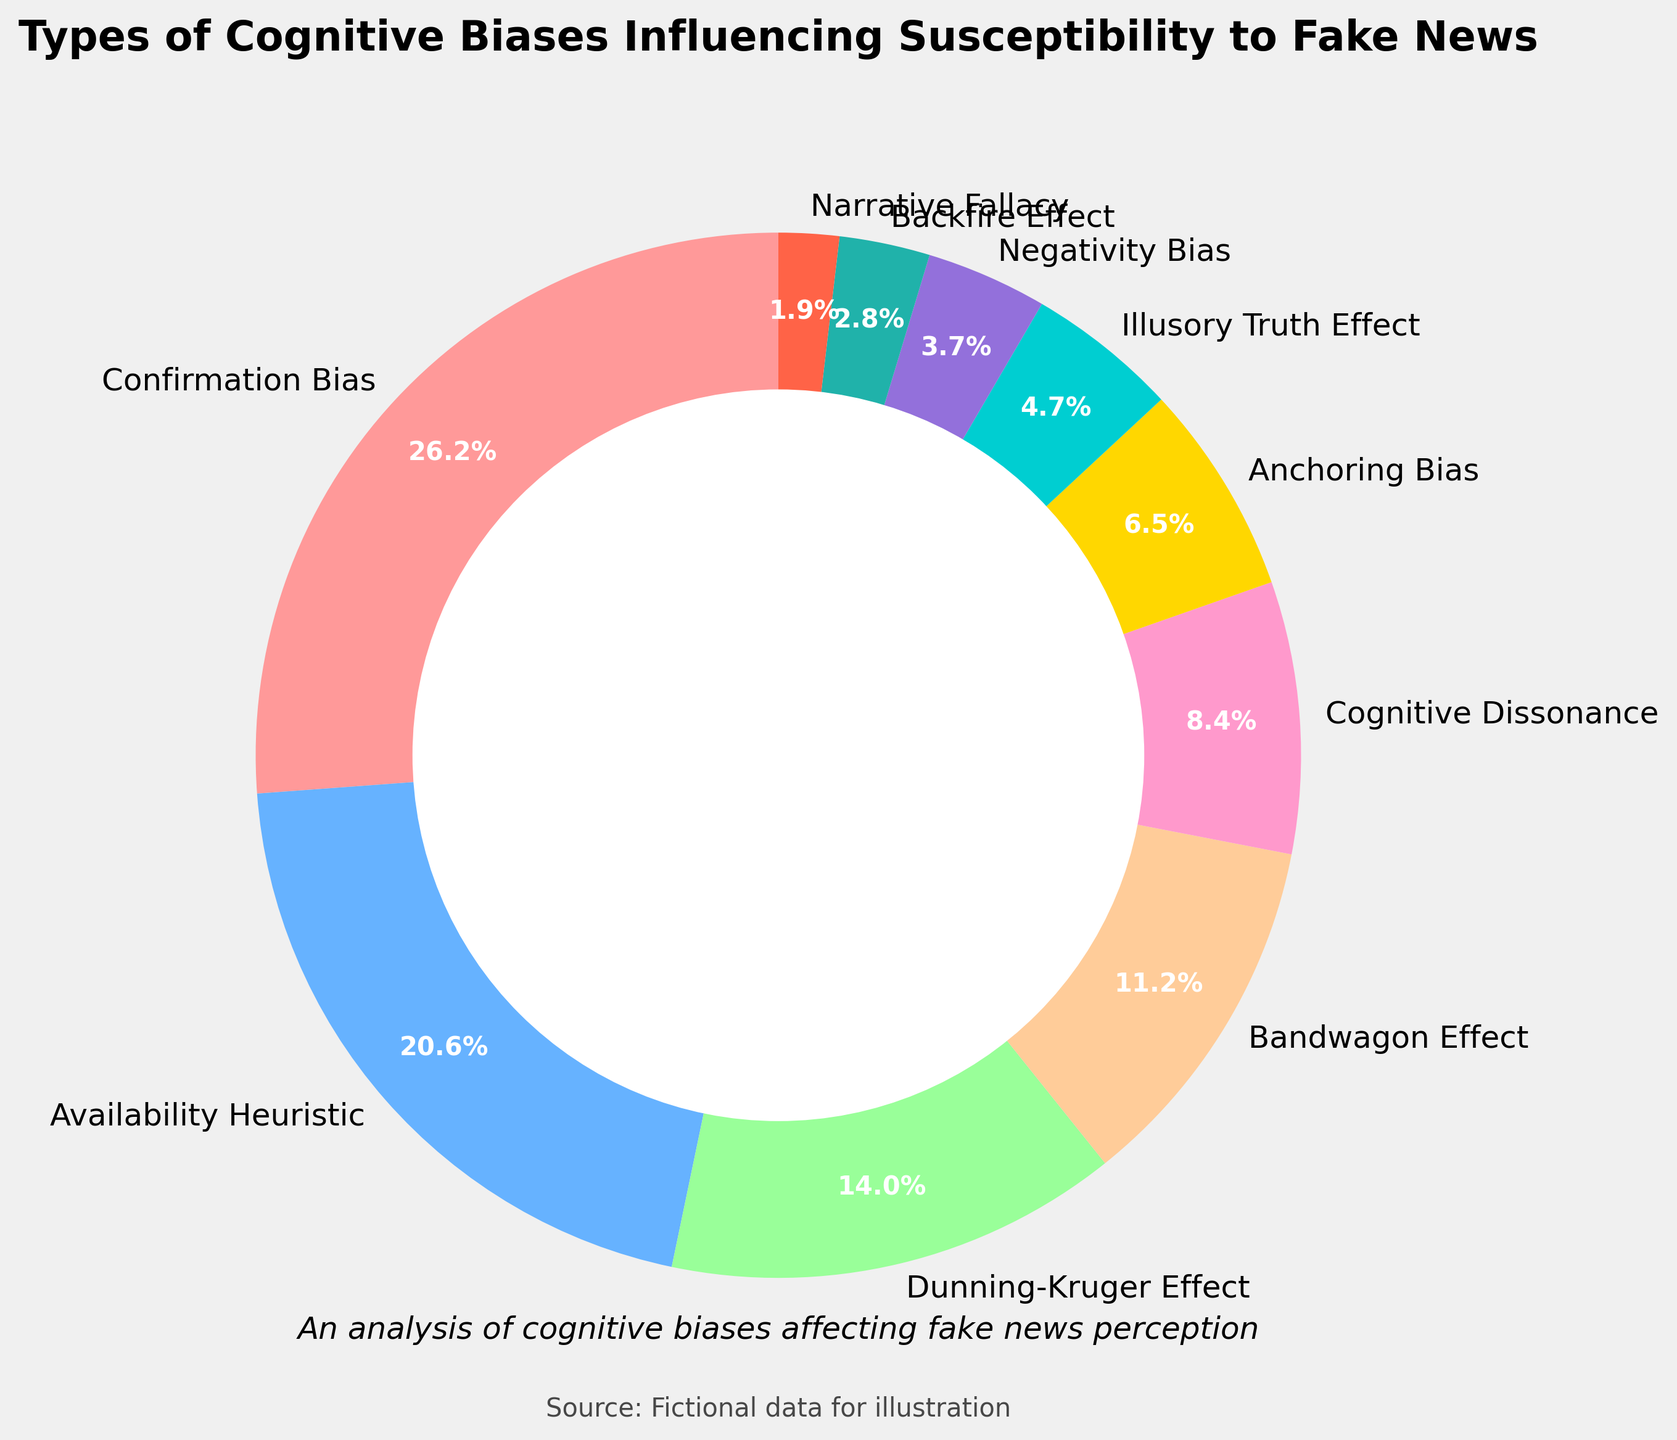What percentage of cognitive biases influencing susceptibility to fake news is due to Confirmation Bias? From the figure, Confirmation Bias makes up 28% of the cognitive biases influencing susceptibility to fake news.
Answer: 28% Which cognitive bias has the second highest influence on susceptibility to fake news? The pie chart shows that the bias with the second highest percentage is the Availability Heuristic at 22%.
Answer: Availability Heuristic Which biases together constitute less than 10% each? From the pie chart, the biases with less than 10% each are Cognitive Dissonance (9%), Anchoring Bias (7%), Illusory Truth Effect (5%), Negativity Bias (4%), Backfire Effect (3%), and Narrative Fallacy (2%).
Answer: Cognitive Dissonance, Anchoring Bias, Illusory Truth Effect, Negativity Bias, Backfire Effect, Narrative Fallacy What is the combined percentage of biases relating to Bandwagon Effect, Cognitive Dissonance, and Anchoring Bias? Adding the percentages of Bandwagon Effect (12%), Cognitive Dissonance (9%), and Anchoring Bias (7%), we get 12 + 9 + 7 = 28%.
Answer: 28% Which bias is represented by the smallest segment on the pie chart, and what is its percentage? The smallest segment on the pie chart is the Narrative Fallacy, which constitutes 2% of the biases.
Answer: Narrative Fallacy, 2% How much more is the percentage for Confirmation Bias than the Dunning-Kruger Effect? The percentage for Confirmation Bias is 28% and for Dunning-Kruger Effect is 15%. The difference is 28 - 15 = 13%.
Answer: 13% Rank the top three biases influencing susceptibility to fake news. The top three biases by percentage are:
1. Confirmation Bias (28%)
2. Availability Heuristic (22%)
3. Dunning-Kruger Effect (15%)
Answer: Confirmation Bias, Availability Heuristic, Dunning-Kruger Effect If we combine the percentages of Availability Heuristic and Dunning-Kruger Effect, does their total exceed that of Confirmation Bias? The Availability Heuristic is 22% and the Dunning-Kruger Effect is 15%. Their combined percentage is 22 + 15 = 37%, which is more than the 28% for Confirmation Bias.
Answer: Yes Which bias represented by a golden (yellow) color, and what is its percentage? The pie chart indicates the golden (yellow) color represents the Illusory Truth Effect at 5%.
Answer: Illusory Truth Effect, 5% How many biases in total are listed in the pie chart? The pie chart lists ten different cognitive biases.
Answer: 10 